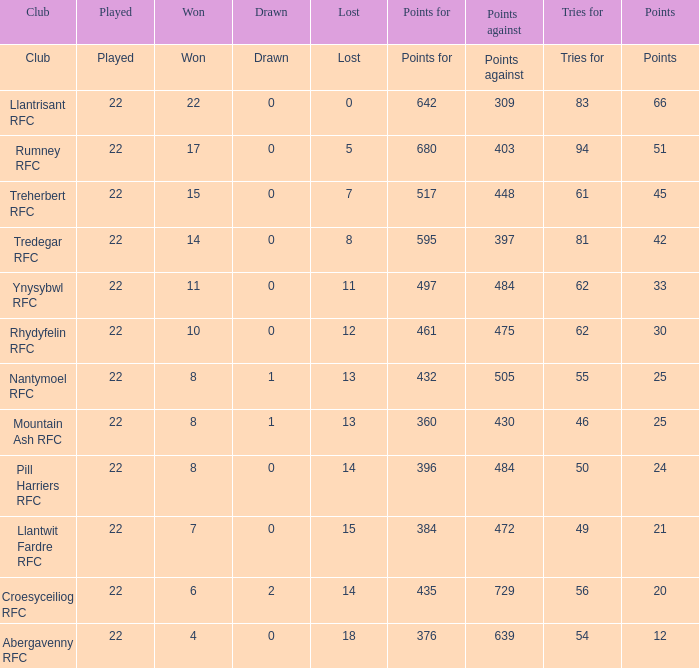In the case of teams that secured 15 triumphs, how many points did they tally? 45.0. Could you parse the entire table as a dict? {'header': ['Club', 'Played', 'Won', 'Drawn', 'Lost', 'Points for', 'Points against', 'Tries for', 'Points'], 'rows': [['Club', 'Played', 'Won', 'Drawn', 'Lost', 'Points for', 'Points against', 'Tries for', 'Points'], ['Llantrisant RFC', '22', '22', '0', '0', '642', '309', '83', '66'], ['Rumney RFC', '22', '17', '0', '5', '680', '403', '94', '51'], ['Treherbert RFC', '22', '15', '0', '7', '517', '448', '61', '45'], ['Tredegar RFC', '22', '14', '0', '8', '595', '397', '81', '42'], ['Ynysybwl RFC', '22', '11', '0', '11', '497', '484', '62', '33'], ['Rhydyfelin RFC', '22', '10', '0', '12', '461', '475', '62', '30'], ['Nantymoel RFC', '22', '8', '1', '13', '432', '505', '55', '25'], ['Mountain Ash RFC', '22', '8', '1', '13', '360', '430', '46', '25'], ['Pill Harriers RFC', '22', '8', '0', '14', '396', '484', '50', '24'], ['Llantwit Fardre RFC', '22', '7', '0', '15', '384', '472', '49', '21'], ['Croesyceiliog RFC', '22', '6', '2', '14', '435', '729', '56', '20'], ['Abergavenny RFC', '22', '4', '0', '18', '376', '639', '54', '12']]} 